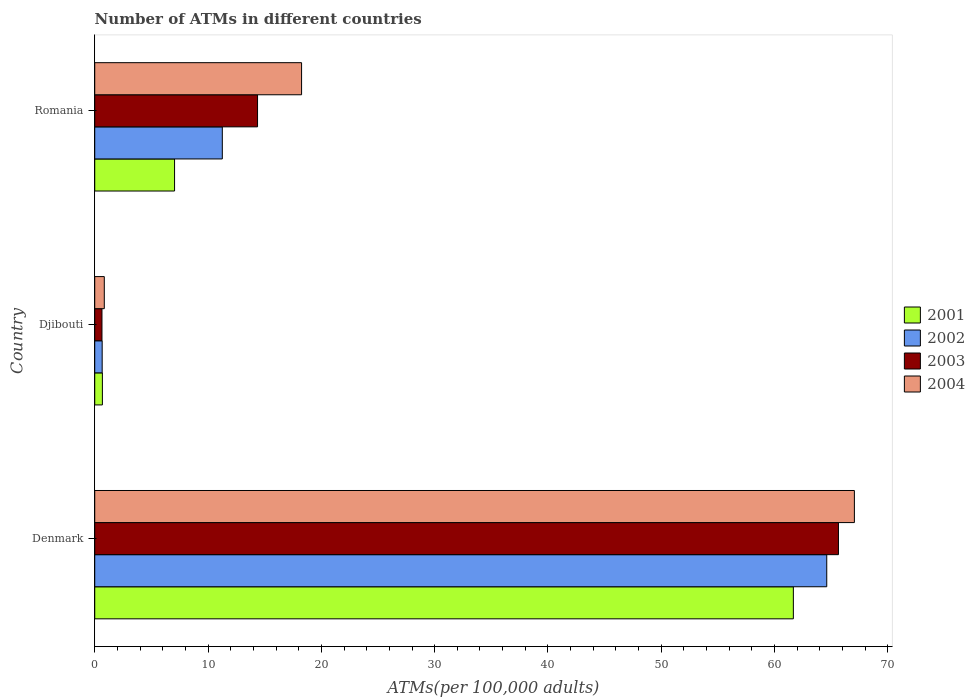How many different coloured bars are there?
Give a very brief answer. 4. Are the number of bars per tick equal to the number of legend labels?
Make the answer very short. Yes. Are the number of bars on each tick of the Y-axis equal?
Keep it short and to the point. Yes. How many bars are there on the 1st tick from the top?
Your response must be concise. 4. How many bars are there on the 1st tick from the bottom?
Offer a very short reply. 4. What is the label of the 2nd group of bars from the top?
Provide a short and direct response. Djibouti. What is the number of ATMs in 2004 in Denmark?
Make the answer very short. 67.04. Across all countries, what is the maximum number of ATMs in 2002?
Keep it short and to the point. 64.61. Across all countries, what is the minimum number of ATMs in 2003?
Offer a very short reply. 0.64. In which country was the number of ATMs in 2001 minimum?
Your response must be concise. Djibouti. What is the total number of ATMs in 2003 in the graph?
Keep it short and to the point. 80.65. What is the difference between the number of ATMs in 2003 in Denmark and that in Djibouti?
Offer a terse response. 65. What is the difference between the number of ATMs in 2003 in Romania and the number of ATMs in 2004 in Denmark?
Your answer should be compact. -52.67. What is the average number of ATMs in 2003 per country?
Your response must be concise. 26.88. What is the difference between the number of ATMs in 2003 and number of ATMs in 2004 in Romania?
Keep it short and to the point. -3.89. What is the ratio of the number of ATMs in 2002 in Djibouti to that in Romania?
Offer a very short reply. 0.06. Is the difference between the number of ATMs in 2003 in Denmark and Djibouti greater than the difference between the number of ATMs in 2004 in Denmark and Djibouti?
Offer a very short reply. No. What is the difference between the highest and the second highest number of ATMs in 2002?
Offer a very short reply. 53.35. What is the difference between the highest and the lowest number of ATMs in 2003?
Your answer should be compact. 65. What does the 3rd bar from the top in Romania represents?
Provide a short and direct response. 2002. What does the 2nd bar from the bottom in Denmark represents?
Your answer should be very brief. 2002. Is it the case that in every country, the sum of the number of ATMs in 2004 and number of ATMs in 2001 is greater than the number of ATMs in 2003?
Provide a succinct answer. Yes. How many countries are there in the graph?
Keep it short and to the point. 3. Are the values on the major ticks of X-axis written in scientific E-notation?
Offer a terse response. No. Does the graph contain any zero values?
Offer a terse response. No. Does the graph contain grids?
Your response must be concise. No. What is the title of the graph?
Ensure brevity in your answer.  Number of ATMs in different countries. Does "2002" appear as one of the legend labels in the graph?
Offer a terse response. Yes. What is the label or title of the X-axis?
Ensure brevity in your answer.  ATMs(per 100,0 adults). What is the ATMs(per 100,000 adults) in 2001 in Denmark?
Provide a succinct answer. 61.66. What is the ATMs(per 100,000 adults) in 2002 in Denmark?
Your answer should be compact. 64.61. What is the ATMs(per 100,000 adults) in 2003 in Denmark?
Your response must be concise. 65.64. What is the ATMs(per 100,000 adults) in 2004 in Denmark?
Your response must be concise. 67.04. What is the ATMs(per 100,000 adults) in 2001 in Djibouti?
Your answer should be compact. 0.68. What is the ATMs(per 100,000 adults) of 2002 in Djibouti?
Your answer should be very brief. 0.66. What is the ATMs(per 100,000 adults) of 2003 in Djibouti?
Your answer should be compact. 0.64. What is the ATMs(per 100,000 adults) in 2004 in Djibouti?
Provide a short and direct response. 0.84. What is the ATMs(per 100,000 adults) of 2001 in Romania?
Offer a very short reply. 7.04. What is the ATMs(per 100,000 adults) in 2002 in Romania?
Keep it short and to the point. 11.26. What is the ATMs(per 100,000 adults) of 2003 in Romania?
Provide a succinct answer. 14.37. What is the ATMs(per 100,000 adults) of 2004 in Romania?
Your answer should be very brief. 18.26. Across all countries, what is the maximum ATMs(per 100,000 adults) in 2001?
Your answer should be very brief. 61.66. Across all countries, what is the maximum ATMs(per 100,000 adults) of 2002?
Ensure brevity in your answer.  64.61. Across all countries, what is the maximum ATMs(per 100,000 adults) in 2003?
Provide a short and direct response. 65.64. Across all countries, what is the maximum ATMs(per 100,000 adults) of 2004?
Your answer should be very brief. 67.04. Across all countries, what is the minimum ATMs(per 100,000 adults) in 2001?
Your answer should be compact. 0.68. Across all countries, what is the minimum ATMs(per 100,000 adults) in 2002?
Offer a very short reply. 0.66. Across all countries, what is the minimum ATMs(per 100,000 adults) of 2003?
Ensure brevity in your answer.  0.64. Across all countries, what is the minimum ATMs(per 100,000 adults) in 2004?
Ensure brevity in your answer.  0.84. What is the total ATMs(per 100,000 adults) of 2001 in the graph?
Offer a very short reply. 69.38. What is the total ATMs(per 100,000 adults) in 2002 in the graph?
Offer a terse response. 76.52. What is the total ATMs(per 100,000 adults) in 2003 in the graph?
Provide a short and direct response. 80.65. What is the total ATMs(per 100,000 adults) in 2004 in the graph?
Provide a short and direct response. 86.14. What is the difference between the ATMs(per 100,000 adults) in 2001 in Denmark and that in Djibouti?
Offer a terse response. 60.98. What is the difference between the ATMs(per 100,000 adults) in 2002 in Denmark and that in Djibouti?
Give a very brief answer. 63.95. What is the difference between the ATMs(per 100,000 adults) in 2003 in Denmark and that in Djibouti?
Your answer should be very brief. 65. What is the difference between the ATMs(per 100,000 adults) in 2004 in Denmark and that in Djibouti?
Your response must be concise. 66.2. What is the difference between the ATMs(per 100,000 adults) in 2001 in Denmark and that in Romania?
Provide a short and direct response. 54.61. What is the difference between the ATMs(per 100,000 adults) in 2002 in Denmark and that in Romania?
Provide a succinct answer. 53.35. What is the difference between the ATMs(per 100,000 adults) in 2003 in Denmark and that in Romania?
Offer a very short reply. 51.27. What is the difference between the ATMs(per 100,000 adults) in 2004 in Denmark and that in Romania?
Give a very brief answer. 48.79. What is the difference between the ATMs(per 100,000 adults) of 2001 in Djibouti and that in Romania?
Your response must be concise. -6.37. What is the difference between the ATMs(per 100,000 adults) in 2002 in Djibouti and that in Romania?
Offer a terse response. -10.6. What is the difference between the ATMs(per 100,000 adults) of 2003 in Djibouti and that in Romania?
Offer a very short reply. -13.73. What is the difference between the ATMs(per 100,000 adults) in 2004 in Djibouti and that in Romania?
Provide a short and direct response. -17.41. What is the difference between the ATMs(per 100,000 adults) of 2001 in Denmark and the ATMs(per 100,000 adults) of 2002 in Djibouti?
Your answer should be compact. 61. What is the difference between the ATMs(per 100,000 adults) of 2001 in Denmark and the ATMs(per 100,000 adults) of 2003 in Djibouti?
Your answer should be compact. 61.02. What is the difference between the ATMs(per 100,000 adults) of 2001 in Denmark and the ATMs(per 100,000 adults) of 2004 in Djibouti?
Your response must be concise. 60.81. What is the difference between the ATMs(per 100,000 adults) in 2002 in Denmark and the ATMs(per 100,000 adults) in 2003 in Djibouti?
Your answer should be very brief. 63.97. What is the difference between the ATMs(per 100,000 adults) in 2002 in Denmark and the ATMs(per 100,000 adults) in 2004 in Djibouti?
Your answer should be very brief. 63.76. What is the difference between the ATMs(per 100,000 adults) in 2003 in Denmark and the ATMs(per 100,000 adults) in 2004 in Djibouti?
Your answer should be very brief. 64.79. What is the difference between the ATMs(per 100,000 adults) in 2001 in Denmark and the ATMs(per 100,000 adults) in 2002 in Romania?
Offer a terse response. 50.4. What is the difference between the ATMs(per 100,000 adults) in 2001 in Denmark and the ATMs(per 100,000 adults) in 2003 in Romania?
Ensure brevity in your answer.  47.29. What is the difference between the ATMs(per 100,000 adults) in 2001 in Denmark and the ATMs(per 100,000 adults) in 2004 in Romania?
Your answer should be very brief. 43.4. What is the difference between the ATMs(per 100,000 adults) of 2002 in Denmark and the ATMs(per 100,000 adults) of 2003 in Romania?
Your response must be concise. 50.24. What is the difference between the ATMs(per 100,000 adults) of 2002 in Denmark and the ATMs(per 100,000 adults) of 2004 in Romania?
Your response must be concise. 46.35. What is the difference between the ATMs(per 100,000 adults) in 2003 in Denmark and the ATMs(per 100,000 adults) in 2004 in Romania?
Ensure brevity in your answer.  47.38. What is the difference between the ATMs(per 100,000 adults) in 2001 in Djibouti and the ATMs(per 100,000 adults) in 2002 in Romania?
Your response must be concise. -10.58. What is the difference between the ATMs(per 100,000 adults) in 2001 in Djibouti and the ATMs(per 100,000 adults) in 2003 in Romania?
Provide a succinct answer. -13.69. What is the difference between the ATMs(per 100,000 adults) in 2001 in Djibouti and the ATMs(per 100,000 adults) in 2004 in Romania?
Ensure brevity in your answer.  -17.58. What is the difference between the ATMs(per 100,000 adults) of 2002 in Djibouti and the ATMs(per 100,000 adults) of 2003 in Romania?
Give a very brief answer. -13.71. What is the difference between the ATMs(per 100,000 adults) in 2002 in Djibouti and the ATMs(per 100,000 adults) in 2004 in Romania?
Ensure brevity in your answer.  -17.6. What is the difference between the ATMs(per 100,000 adults) in 2003 in Djibouti and the ATMs(per 100,000 adults) in 2004 in Romania?
Provide a short and direct response. -17.62. What is the average ATMs(per 100,000 adults) of 2001 per country?
Offer a terse response. 23.13. What is the average ATMs(per 100,000 adults) in 2002 per country?
Give a very brief answer. 25.51. What is the average ATMs(per 100,000 adults) of 2003 per country?
Make the answer very short. 26.88. What is the average ATMs(per 100,000 adults) in 2004 per country?
Make the answer very short. 28.71. What is the difference between the ATMs(per 100,000 adults) in 2001 and ATMs(per 100,000 adults) in 2002 in Denmark?
Your answer should be very brief. -2.95. What is the difference between the ATMs(per 100,000 adults) of 2001 and ATMs(per 100,000 adults) of 2003 in Denmark?
Your response must be concise. -3.98. What is the difference between the ATMs(per 100,000 adults) of 2001 and ATMs(per 100,000 adults) of 2004 in Denmark?
Give a very brief answer. -5.39. What is the difference between the ATMs(per 100,000 adults) of 2002 and ATMs(per 100,000 adults) of 2003 in Denmark?
Ensure brevity in your answer.  -1.03. What is the difference between the ATMs(per 100,000 adults) of 2002 and ATMs(per 100,000 adults) of 2004 in Denmark?
Your response must be concise. -2.44. What is the difference between the ATMs(per 100,000 adults) of 2003 and ATMs(per 100,000 adults) of 2004 in Denmark?
Provide a succinct answer. -1.41. What is the difference between the ATMs(per 100,000 adults) of 2001 and ATMs(per 100,000 adults) of 2002 in Djibouti?
Ensure brevity in your answer.  0.02. What is the difference between the ATMs(per 100,000 adults) of 2001 and ATMs(per 100,000 adults) of 2003 in Djibouti?
Offer a terse response. 0.04. What is the difference between the ATMs(per 100,000 adults) of 2001 and ATMs(per 100,000 adults) of 2004 in Djibouti?
Provide a succinct answer. -0.17. What is the difference between the ATMs(per 100,000 adults) in 2002 and ATMs(per 100,000 adults) in 2003 in Djibouti?
Provide a short and direct response. 0.02. What is the difference between the ATMs(per 100,000 adults) of 2002 and ATMs(per 100,000 adults) of 2004 in Djibouti?
Provide a succinct answer. -0.19. What is the difference between the ATMs(per 100,000 adults) of 2003 and ATMs(per 100,000 adults) of 2004 in Djibouti?
Your answer should be very brief. -0.21. What is the difference between the ATMs(per 100,000 adults) in 2001 and ATMs(per 100,000 adults) in 2002 in Romania?
Keep it short and to the point. -4.21. What is the difference between the ATMs(per 100,000 adults) in 2001 and ATMs(per 100,000 adults) in 2003 in Romania?
Your answer should be very brief. -7.32. What is the difference between the ATMs(per 100,000 adults) of 2001 and ATMs(per 100,000 adults) of 2004 in Romania?
Make the answer very short. -11.21. What is the difference between the ATMs(per 100,000 adults) of 2002 and ATMs(per 100,000 adults) of 2003 in Romania?
Offer a terse response. -3.11. What is the difference between the ATMs(per 100,000 adults) of 2002 and ATMs(per 100,000 adults) of 2004 in Romania?
Provide a short and direct response. -7. What is the difference between the ATMs(per 100,000 adults) of 2003 and ATMs(per 100,000 adults) of 2004 in Romania?
Make the answer very short. -3.89. What is the ratio of the ATMs(per 100,000 adults) in 2001 in Denmark to that in Djibouti?
Your answer should be compact. 91.18. What is the ratio of the ATMs(per 100,000 adults) in 2002 in Denmark to that in Djibouti?
Make the answer very short. 98.45. What is the ratio of the ATMs(per 100,000 adults) of 2003 in Denmark to that in Djibouti?
Your answer should be very brief. 102.88. What is the ratio of the ATMs(per 100,000 adults) of 2004 in Denmark to that in Djibouti?
Your response must be concise. 79.46. What is the ratio of the ATMs(per 100,000 adults) in 2001 in Denmark to that in Romania?
Your response must be concise. 8.75. What is the ratio of the ATMs(per 100,000 adults) of 2002 in Denmark to that in Romania?
Keep it short and to the point. 5.74. What is the ratio of the ATMs(per 100,000 adults) of 2003 in Denmark to that in Romania?
Your answer should be very brief. 4.57. What is the ratio of the ATMs(per 100,000 adults) in 2004 in Denmark to that in Romania?
Provide a succinct answer. 3.67. What is the ratio of the ATMs(per 100,000 adults) of 2001 in Djibouti to that in Romania?
Your answer should be compact. 0.1. What is the ratio of the ATMs(per 100,000 adults) in 2002 in Djibouti to that in Romania?
Ensure brevity in your answer.  0.06. What is the ratio of the ATMs(per 100,000 adults) in 2003 in Djibouti to that in Romania?
Provide a short and direct response. 0.04. What is the ratio of the ATMs(per 100,000 adults) in 2004 in Djibouti to that in Romania?
Provide a succinct answer. 0.05. What is the difference between the highest and the second highest ATMs(per 100,000 adults) in 2001?
Give a very brief answer. 54.61. What is the difference between the highest and the second highest ATMs(per 100,000 adults) of 2002?
Provide a short and direct response. 53.35. What is the difference between the highest and the second highest ATMs(per 100,000 adults) of 2003?
Your answer should be compact. 51.27. What is the difference between the highest and the second highest ATMs(per 100,000 adults) of 2004?
Make the answer very short. 48.79. What is the difference between the highest and the lowest ATMs(per 100,000 adults) in 2001?
Give a very brief answer. 60.98. What is the difference between the highest and the lowest ATMs(per 100,000 adults) in 2002?
Offer a very short reply. 63.95. What is the difference between the highest and the lowest ATMs(per 100,000 adults) in 2003?
Your answer should be compact. 65. What is the difference between the highest and the lowest ATMs(per 100,000 adults) of 2004?
Keep it short and to the point. 66.2. 